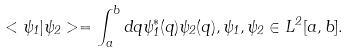<formula> <loc_0><loc_0><loc_500><loc_500>< \psi _ { 1 } | \psi _ { 2 } > = \int _ { a } ^ { b } d q \psi ^ { * } _ { 1 } ( q ) \psi _ { 2 } ( q ) , \psi _ { 1 } , \psi _ { 2 } \in L ^ { 2 } [ a , b ] .</formula> 